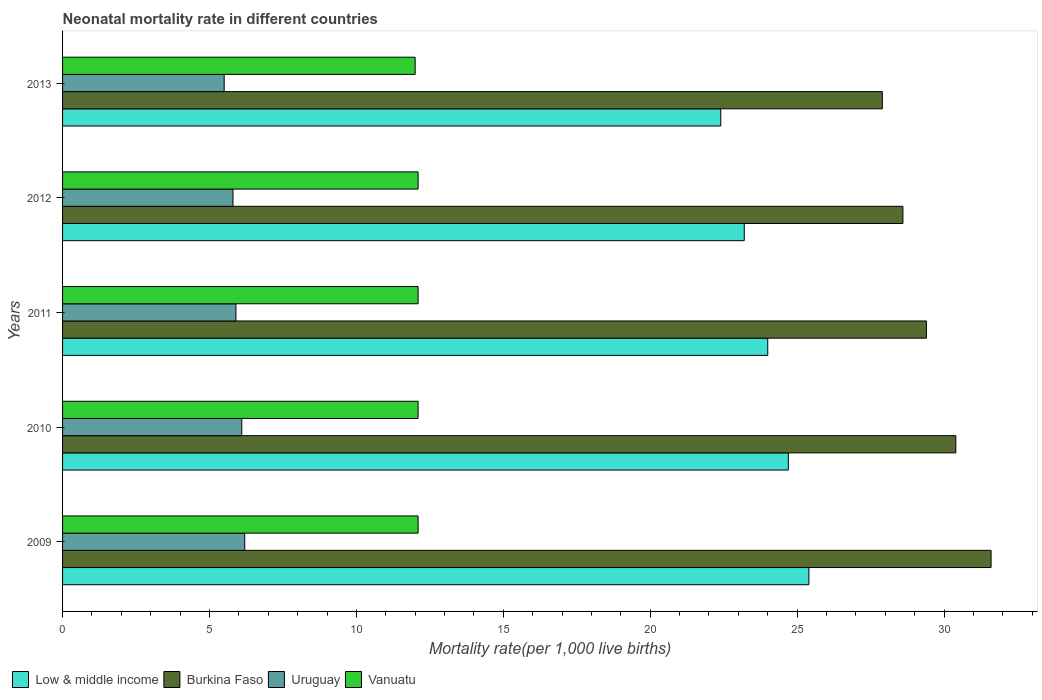How many different coloured bars are there?
Your answer should be compact. 4. How many groups of bars are there?
Offer a very short reply. 5. Are the number of bars per tick equal to the number of legend labels?
Your response must be concise. Yes. How many bars are there on the 3rd tick from the top?
Offer a terse response. 4. How many bars are there on the 1st tick from the bottom?
Give a very brief answer. 4. What is the neonatal mortality rate in Uruguay in 2012?
Make the answer very short. 5.8. Across all years, what is the maximum neonatal mortality rate in Burkina Faso?
Provide a succinct answer. 31.6. Across all years, what is the minimum neonatal mortality rate in Burkina Faso?
Ensure brevity in your answer.  27.9. In which year was the neonatal mortality rate in Vanuatu maximum?
Provide a short and direct response. 2009. In which year was the neonatal mortality rate in Vanuatu minimum?
Make the answer very short. 2013. What is the total neonatal mortality rate in Burkina Faso in the graph?
Offer a very short reply. 147.9. What is the difference between the neonatal mortality rate in Low & middle income in 2009 and that in 2012?
Your answer should be very brief. 2.2. What is the difference between the neonatal mortality rate in Vanuatu in 2009 and the neonatal mortality rate in Burkina Faso in 2012?
Ensure brevity in your answer.  -16.5. What is the average neonatal mortality rate in Low & middle income per year?
Offer a terse response. 23.94. In the year 2013, what is the difference between the neonatal mortality rate in Low & middle income and neonatal mortality rate in Burkina Faso?
Ensure brevity in your answer.  -5.5. In how many years, is the neonatal mortality rate in Burkina Faso greater than 7 ?
Give a very brief answer. 5. What is the ratio of the neonatal mortality rate in Vanuatu in 2011 to that in 2013?
Offer a very short reply. 1.01. What is the difference between the highest and the lowest neonatal mortality rate in Low & middle income?
Provide a succinct answer. 3. In how many years, is the neonatal mortality rate in Uruguay greater than the average neonatal mortality rate in Uruguay taken over all years?
Keep it short and to the point. 2. Is the sum of the neonatal mortality rate in Burkina Faso in 2009 and 2010 greater than the maximum neonatal mortality rate in Low & middle income across all years?
Offer a very short reply. Yes. What does the 3rd bar from the bottom in 2013 represents?
Ensure brevity in your answer.  Uruguay. Are all the bars in the graph horizontal?
Your answer should be very brief. Yes. What is the difference between two consecutive major ticks on the X-axis?
Make the answer very short. 5. Are the values on the major ticks of X-axis written in scientific E-notation?
Provide a succinct answer. No. Does the graph contain any zero values?
Keep it short and to the point. No. Does the graph contain grids?
Your response must be concise. No. Where does the legend appear in the graph?
Give a very brief answer. Bottom left. What is the title of the graph?
Give a very brief answer. Neonatal mortality rate in different countries. What is the label or title of the X-axis?
Offer a terse response. Mortality rate(per 1,0 live births). What is the Mortality rate(per 1,000 live births) of Low & middle income in 2009?
Provide a short and direct response. 25.4. What is the Mortality rate(per 1,000 live births) in Burkina Faso in 2009?
Provide a short and direct response. 31.6. What is the Mortality rate(per 1,000 live births) in Low & middle income in 2010?
Ensure brevity in your answer.  24.7. What is the Mortality rate(per 1,000 live births) of Burkina Faso in 2010?
Offer a terse response. 30.4. What is the Mortality rate(per 1,000 live births) in Uruguay in 2010?
Your answer should be compact. 6.1. What is the Mortality rate(per 1,000 live births) of Vanuatu in 2010?
Your response must be concise. 12.1. What is the Mortality rate(per 1,000 live births) in Low & middle income in 2011?
Ensure brevity in your answer.  24. What is the Mortality rate(per 1,000 live births) of Burkina Faso in 2011?
Your answer should be compact. 29.4. What is the Mortality rate(per 1,000 live births) of Uruguay in 2011?
Give a very brief answer. 5.9. What is the Mortality rate(per 1,000 live births) of Low & middle income in 2012?
Provide a short and direct response. 23.2. What is the Mortality rate(per 1,000 live births) of Burkina Faso in 2012?
Your answer should be compact. 28.6. What is the Mortality rate(per 1,000 live births) in Uruguay in 2012?
Make the answer very short. 5.8. What is the Mortality rate(per 1,000 live births) in Low & middle income in 2013?
Make the answer very short. 22.4. What is the Mortality rate(per 1,000 live births) in Burkina Faso in 2013?
Ensure brevity in your answer.  27.9. What is the Mortality rate(per 1,000 live births) in Vanuatu in 2013?
Provide a short and direct response. 12. Across all years, what is the maximum Mortality rate(per 1,000 live births) of Low & middle income?
Offer a very short reply. 25.4. Across all years, what is the maximum Mortality rate(per 1,000 live births) in Burkina Faso?
Provide a short and direct response. 31.6. Across all years, what is the maximum Mortality rate(per 1,000 live births) in Uruguay?
Ensure brevity in your answer.  6.2. Across all years, what is the maximum Mortality rate(per 1,000 live births) in Vanuatu?
Offer a very short reply. 12.1. Across all years, what is the minimum Mortality rate(per 1,000 live births) of Low & middle income?
Make the answer very short. 22.4. Across all years, what is the minimum Mortality rate(per 1,000 live births) of Burkina Faso?
Offer a terse response. 27.9. Across all years, what is the minimum Mortality rate(per 1,000 live births) of Uruguay?
Ensure brevity in your answer.  5.5. Across all years, what is the minimum Mortality rate(per 1,000 live births) in Vanuatu?
Make the answer very short. 12. What is the total Mortality rate(per 1,000 live births) in Low & middle income in the graph?
Your answer should be very brief. 119.7. What is the total Mortality rate(per 1,000 live births) of Burkina Faso in the graph?
Give a very brief answer. 147.9. What is the total Mortality rate(per 1,000 live births) of Uruguay in the graph?
Give a very brief answer. 29.5. What is the total Mortality rate(per 1,000 live births) in Vanuatu in the graph?
Provide a succinct answer. 60.4. What is the difference between the Mortality rate(per 1,000 live births) of Vanuatu in 2009 and that in 2010?
Give a very brief answer. 0. What is the difference between the Mortality rate(per 1,000 live births) in Uruguay in 2009 and that in 2011?
Your response must be concise. 0.3. What is the difference between the Mortality rate(per 1,000 live births) in Low & middle income in 2009 and that in 2012?
Offer a terse response. 2.2. What is the difference between the Mortality rate(per 1,000 live births) in Uruguay in 2009 and that in 2012?
Offer a terse response. 0.4. What is the difference between the Mortality rate(per 1,000 live births) in Vanuatu in 2009 and that in 2012?
Your answer should be compact. 0. What is the difference between the Mortality rate(per 1,000 live births) in Low & middle income in 2009 and that in 2013?
Your response must be concise. 3. What is the difference between the Mortality rate(per 1,000 live births) of Uruguay in 2009 and that in 2013?
Your response must be concise. 0.7. What is the difference between the Mortality rate(per 1,000 live births) in Vanuatu in 2009 and that in 2013?
Ensure brevity in your answer.  0.1. What is the difference between the Mortality rate(per 1,000 live births) of Burkina Faso in 2010 and that in 2011?
Offer a terse response. 1. What is the difference between the Mortality rate(per 1,000 live births) in Vanuatu in 2010 and that in 2011?
Offer a terse response. 0. What is the difference between the Mortality rate(per 1,000 live births) of Low & middle income in 2010 and that in 2012?
Give a very brief answer. 1.5. What is the difference between the Mortality rate(per 1,000 live births) of Uruguay in 2010 and that in 2012?
Give a very brief answer. 0.3. What is the difference between the Mortality rate(per 1,000 live births) in Low & middle income in 2010 and that in 2013?
Provide a short and direct response. 2.3. What is the difference between the Mortality rate(per 1,000 live births) in Uruguay in 2010 and that in 2013?
Your answer should be very brief. 0.6. What is the difference between the Mortality rate(per 1,000 live births) of Uruguay in 2011 and that in 2012?
Make the answer very short. 0.1. What is the difference between the Mortality rate(per 1,000 live births) in Low & middle income in 2011 and that in 2013?
Your answer should be compact. 1.6. What is the difference between the Mortality rate(per 1,000 live births) of Low & middle income in 2012 and that in 2013?
Ensure brevity in your answer.  0.8. What is the difference between the Mortality rate(per 1,000 live births) of Low & middle income in 2009 and the Mortality rate(per 1,000 live births) of Burkina Faso in 2010?
Your answer should be very brief. -5. What is the difference between the Mortality rate(per 1,000 live births) of Low & middle income in 2009 and the Mortality rate(per 1,000 live births) of Uruguay in 2010?
Ensure brevity in your answer.  19.3. What is the difference between the Mortality rate(per 1,000 live births) of Burkina Faso in 2009 and the Mortality rate(per 1,000 live births) of Uruguay in 2010?
Your answer should be compact. 25.5. What is the difference between the Mortality rate(per 1,000 live births) in Burkina Faso in 2009 and the Mortality rate(per 1,000 live births) in Vanuatu in 2010?
Offer a terse response. 19.5. What is the difference between the Mortality rate(per 1,000 live births) in Uruguay in 2009 and the Mortality rate(per 1,000 live births) in Vanuatu in 2010?
Ensure brevity in your answer.  -5.9. What is the difference between the Mortality rate(per 1,000 live births) of Low & middle income in 2009 and the Mortality rate(per 1,000 live births) of Burkina Faso in 2011?
Provide a succinct answer. -4. What is the difference between the Mortality rate(per 1,000 live births) in Low & middle income in 2009 and the Mortality rate(per 1,000 live births) in Uruguay in 2011?
Your answer should be very brief. 19.5. What is the difference between the Mortality rate(per 1,000 live births) in Low & middle income in 2009 and the Mortality rate(per 1,000 live births) in Vanuatu in 2011?
Offer a terse response. 13.3. What is the difference between the Mortality rate(per 1,000 live births) in Burkina Faso in 2009 and the Mortality rate(per 1,000 live births) in Uruguay in 2011?
Your response must be concise. 25.7. What is the difference between the Mortality rate(per 1,000 live births) of Low & middle income in 2009 and the Mortality rate(per 1,000 live births) of Uruguay in 2012?
Provide a succinct answer. 19.6. What is the difference between the Mortality rate(per 1,000 live births) in Burkina Faso in 2009 and the Mortality rate(per 1,000 live births) in Uruguay in 2012?
Provide a short and direct response. 25.8. What is the difference between the Mortality rate(per 1,000 live births) in Burkina Faso in 2009 and the Mortality rate(per 1,000 live births) in Uruguay in 2013?
Ensure brevity in your answer.  26.1. What is the difference between the Mortality rate(per 1,000 live births) in Burkina Faso in 2009 and the Mortality rate(per 1,000 live births) in Vanuatu in 2013?
Your answer should be compact. 19.6. What is the difference between the Mortality rate(per 1,000 live births) of Uruguay in 2010 and the Mortality rate(per 1,000 live births) of Vanuatu in 2011?
Offer a terse response. -6. What is the difference between the Mortality rate(per 1,000 live births) in Low & middle income in 2010 and the Mortality rate(per 1,000 live births) in Vanuatu in 2012?
Provide a short and direct response. 12.6. What is the difference between the Mortality rate(per 1,000 live births) in Burkina Faso in 2010 and the Mortality rate(per 1,000 live births) in Uruguay in 2012?
Offer a terse response. 24.6. What is the difference between the Mortality rate(per 1,000 live births) in Low & middle income in 2010 and the Mortality rate(per 1,000 live births) in Burkina Faso in 2013?
Give a very brief answer. -3.2. What is the difference between the Mortality rate(per 1,000 live births) of Burkina Faso in 2010 and the Mortality rate(per 1,000 live births) of Uruguay in 2013?
Offer a very short reply. 24.9. What is the difference between the Mortality rate(per 1,000 live births) of Burkina Faso in 2010 and the Mortality rate(per 1,000 live births) of Vanuatu in 2013?
Provide a short and direct response. 18.4. What is the difference between the Mortality rate(per 1,000 live births) in Low & middle income in 2011 and the Mortality rate(per 1,000 live births) in Burkina Faso in 2012?
Offer a very short reply. -4.6. What is the difference between the Mortality rate(per 1,000 live births) of Burkina Faso in 2011 and the Mortality rate(per 1,000 live births) of Uruguay in 2012?
Make the answer very short. 23.6. What is the difference between the Mortality rate(per 1,000 live births) in Burkina Faso in 2011 and the Mortality rate(per 1,000 live births) in Vanuatu in 2012?
Make the answer very short. 17.3. What is the difference between the Mortality rate(per 1,000 live births) in Burkina Faso in 2011 and the Mortality rate(per 1,000 live births) in Uruguay in 2013?
Your answer should be compact. 23.9. What is the difference between the Mortality rate(per 1,000 live births) in Low & middle income in 2012 and the Mortality rate(per 1,000 live births) in Burkina Faso in 2013?
Your answer should be very brief. -4.7. What is the difference between the Mortality rate(per 1,000 live births) in Low & middle income in 2012 and the Mortality rate(per 1,000 live births) in Vanuatu in 2013?
Keep it short and to the point. 11.2. What is the difference between the Mortality rate(per 1,000 live births) of Burkina Faso in 2012 and the Mortality rate(per 1,000 live births) of Uruguay in 2013?
Your answer should be compact. 23.1. What is the difference between the Mortality rate(per 1,000 live births) of Burkina Faso in 2012 and the Mortality rate(per 1,000 live births) of Vanuatu in 2013?
Ensure brevity in your answer.  16.6. What is the average Mortality rate(per 1,000 live births) of Low & middle income per year?
Provide a succinct answer. 23.94. What is the average Mortality rate(per 1,000 live births) in Burkina Faso per year?
Offer a very short reply. 29.58. What is the average Mortality rate(per 1,000 live births) in Vanuatu per year?
Provide a short and direct response. 12.08. In the year 2009, what is the difference between the Mortality rate(per 1,000 live births) of Burkina Faso and Mortality rate(per 1,000 live births) of Uruguay?
Your answer should be compact. 25.4. In the year 2009, what is the difference between the Mortality rate(per 1,000 live births) in Burkina Faso and Mortality rate(per 1,000 live births) in Vanuatu?
Your answer should be very brief. 19.5. In the year 2010, what is the difference between the Mortality rate(per 1,000 live births) in Low & middle income and Mortality rate(per 1,000 live births) in Uruguay?
Your response must be concise. 18.6. In the year 2010, what is the difference between the Mortality rate(per 1,000 live births) in Burkina Faso and Mortality rate(per 1,000 live births) in Uruguay?
Make the answer very short. 24.3. In the year 2011, what is the difference between the Mortality rate(per 1,000 live births) of Low & middle income and Mortality rate(per 1,000 live births) of Burkina Faso?
Give a very brief answer. -5.4. In the year 2011, what is the difference between the Mortality rate(per 1,000 live births) of Low & middle income and Mortality rate(per 1,000 live births) of Vanuatu?
Provide a succinct answer. 11.9. In the year 2011, what is the difference between the Mortality rate(per 1,000 live births) in Burkina Faso and Mortality rate(per 1,000 live births) in Uruguay?
Your response must be concise. 23.5. In the year 2011, what is the difference between the Mortality rate(per 1,000 live births) in Uruguay and Mortality rate(per 1,000 live births) in Vanuatu?
Provide a succinct answer. -6.2. In the year 2012, what is the difference between the Mortality rate(per 1,000 live births) of Low & middle income and Mortality rate(per 1,000 live births) of Burkina Faso?
Your answer should be compact. -5.4. In the year 2012, what is the difference between the Mortality rate(per 1,000 live births) in Burkina Faso and Mortality rate(per 1,000 live births) in Uruguay?
Provide a short and direct response. 22.8. In the year 2012, what is the difference between the Mortality rate(per 1,000 live births) in Burkina Faso and Mortality rate(per 1,000 live births) in Vanuatu?
Your answer should be very brief. 16.5. In the year 2012, what is the difference between the Mortality rate(per 1,000 live births) in Uruguay and Mortality rate(per 1,000 live births) in Vanuatu?
Offer a terse response. -6.3. In the year 2013, what is the difference between the Mortality rate(per 1,000 live births) in Low & middle income and Mortality rate(per 1,000 live births) in Uruguay?
Keep it short and to the point. 16.9. In the year 2013, what is the difference between the Mortality rate(per 1,000 live births) in Burkina Faso and Mortality rate(per 1,000 live births) in Uruguay?
Make the answer very short. 22.4. In the year 2013, what is the difference between the Mortality rate(per 1,000 live births) in Burkina Faso and Mortality rate(per 1,000 live births) in Vanuatu?
Offer a very short reply. 15.9. In the year 2013, what is the difference between the Mortality rate(per 1,000 live births) in Uruguay and Mortality rate(per 1,000 live births) in Vanuatu?
Provide a succinct answer. -6.5. What is the ratio of the Mortality rate(per 1,000 live births) in Low & middle income in 2009 to that in 2010?
Make the answer very short. 1.03. What is the ratio of the Mortality rate(per 1,000 live births) in Burkina Faso in 2009 to that in 2010?
Make the answer very short. 1.04. What is the ratio of the Mortality rate(per 1,000 live births) of Uruguay in 2009 to that in 2010?
Give a very brief answer. 1.02. What is the ratio of the Mortality rate(per 1,000 live births) in Low & middle income in 2009 to that in 2011?
Offer a very short reply. 1.06. What is the ratio of the Mortality rate(per 1,000 live births) of Burkina Faso in 2009 to that in 2011?
Your response must be concise. 1.07. What is the ratio of the Mortality rate(per 1,000 live births) of Uruguay in 2009 to that in 2011?
Ensure brevity in your answer.  1.05. What is the ratio of the Mortality rate(per 1,000 live births) of Low & middle income in 2009 to that in 2012?
Ensure brevity in your answer.  1.09. What is the ratio of the Mortality rate(per 1,000 live births) of Burkina Faso in 2009 to that in 2012?
Offer a terse response. 1.1. What is the ratio of the Mortality rate(per 1,000 live births) in Uruguay in 2009 to that in 2012?
Ensure brevity in your answer.  1.07. What is the ratio of the Mortality rate(per 1,000 live births) in Low & middle income in 2009 to that in 2013?
Make the answer very short. 1.13. What is the ratio of the Mortality rate(per 1,000 live births) of Burkina Faso in 2009 to that in 2013?
Make the answer very short. 1.13. What is the ratio of the Mortality rate(per 1,000 live births) in Uruguay in 2009 to that in 2013?
Keep it short and to the point. 1.13. What is the ratio of the Mortality rate(per 1,000 live births) in Vanuatu in 2009 to that in 2013?
Offer a very short reply. 1.01. What is the ratio of the Mortality rate(per 1,000 live births) in Low & middle income in 2010 to that in 2011?
Provide a short and direct response. 1.03. What is the ratio of the Mortality rate(per 1,000 live births) in Burkina Faso in 2010 to that in 2011?
Give a very brief answer. 1.03. What is the ratio of the Mortality rate(per 1,000 live births) in Uruguay in 2010 to that in 2011?
Provide a succinct answer. 1.03. What is the ratio of the Mortality rate(per 1,000 live births) of Vanuatu in 2010 to that in 2011?
Provide a succinct answer. 1. What is the ratio of the Mortality rate(per 1,000 live births) in Low & middle income in 2010 to that in 2012?
Your answer should be compact. 1.06. What is the ratio of the Mortality rate(per 1,000 live births) of Burkina Faso in 2010 to that in 2012?
Your answer should be compact. 1.06. What is the ratio of the Mortality rate(per 1,000 live births) in Uruguay in 2010 to that in 2012?
Give a very brief answer. 1.05. What is the ratio of the Mortality rate(per 1,000 live births) of Vanuatu in 2010 to that in 2012?
Provide a short and direct response. 1. What is the ratio of the Mortality rate(per 1,000 live births) in Low & middle income in 2010 to that in 2013?
Ensure brevity in your answer.  1.1. What is the ratio of the Mortality rate(per 1,000 live births) of Burkina Faso in 2010 to that in 2013?
Make the answer very short. 1.09. What is the ratio of the Mortality rate(per 1,000 live births) in Uruguay in 2010 to that in 2013?
Your answer should be very brief. 1.11. What is the ratio of the Mortality rate(per 1,000 live births) of Vanuatu in 2010 to that in 2013?
Provide a short and direct response. 1.01. What is the ratio of the Mortality rate(per 1,000 live births) of Low & middle income in 2011 to that in 2012?
Your response must be concise. 1.03. What is the ratio of the Mortality rate(per 1,000 live births) of Burkina Faso in 2011 to that in 2012?
Your answer should be compact. 1.03. What is the ratio of the Mortality rate(per 1,000 live births) of Uruguay in 2011 to that in 2012?
Offer a terse response. 1.02. What is the ratio of the Mortality rate(per 1,000 live births) of Low & middle income in 2011 to that in 2013?
Your answer should be very brief. 1.07. What is the ratio of the Mortality rate(per 1,000 live births) in Burkina Faso in 2011 to that in 2013?
Offer a very short reply. 1.05. What is the ratio of the Mortality rate(per 1,000 live births) in Uruguay in 2011 to that in 2013?
Provide a succinct answer. 1.07. What is the ratio of the Mortality rate(per 1,000 live births) of Vanuatu in 2011 to that in 2013?
Provide a short and direct response. 1.01. What is the ratio of the Mortality rate(per 1,000 live births) in Low & middle income in 2012 to that in 2013?
Offer a very short reply. 1.04. What is the ratio of the Mortality rate(per 1,000 live births) of Burkina Faso in 2012 to that in 2013?
Your answer should be compact. 1.03. What is the ratio of the Mortality rate(per 1,000 live births) of Uruguay in 2012 to that in 2013?
Your answer should be very brief. 1.05. What is the ratio of the Mortality rate(per 1,000 live births) in Vanuatu in 2012 to that in 2013?
Your answer should be very brief. 1.01. What is the difference between the highest and the second highest Mortality rate(per 1,000 live births) in Low & middle income?
Keep it short and to the point. 0.7. What is the difference between the highest and the second highest Mortality rate(per 1,000 live births) in Burkina Faso?
Ensure brevity in your answer.  1.2. What is the difference between the highest and the second highest Mortality rate(per 1,000 live births) in Vanuatu?
Make the answer very short. 0. What is the difference between the highest and the lowest Mortality rate(per 1,000 live births) of Low & middle income?
Provide a succinct answer. 3. 